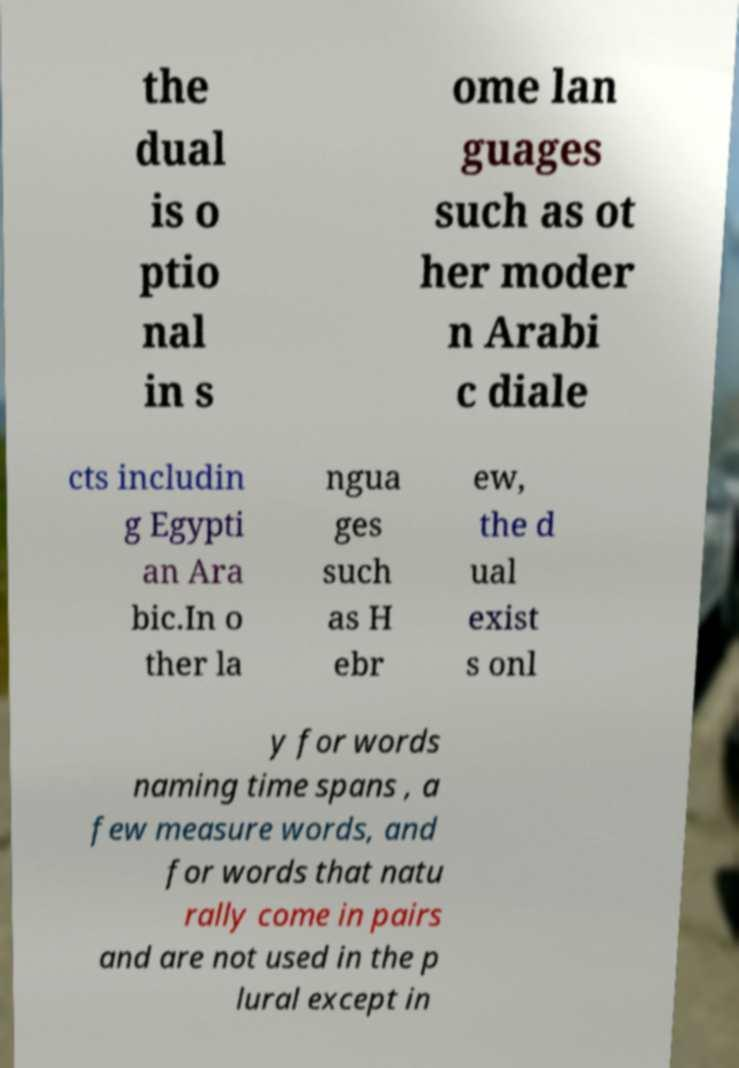Can you read and provide the text displayed in the image?This photo seems to have some interesting text. Can you extract and type it out for me? the dual is o ptio nal in s ome lan guages such as ot her moder n Arabi c diale cts includin g Egypti an Ara bic.In o ther la ngua ges such as H ebr ew, the d ual exist s onl y for words naming time spans , a few measure words, and for words that natu rally come in pairs and are not used in the p lural except in 